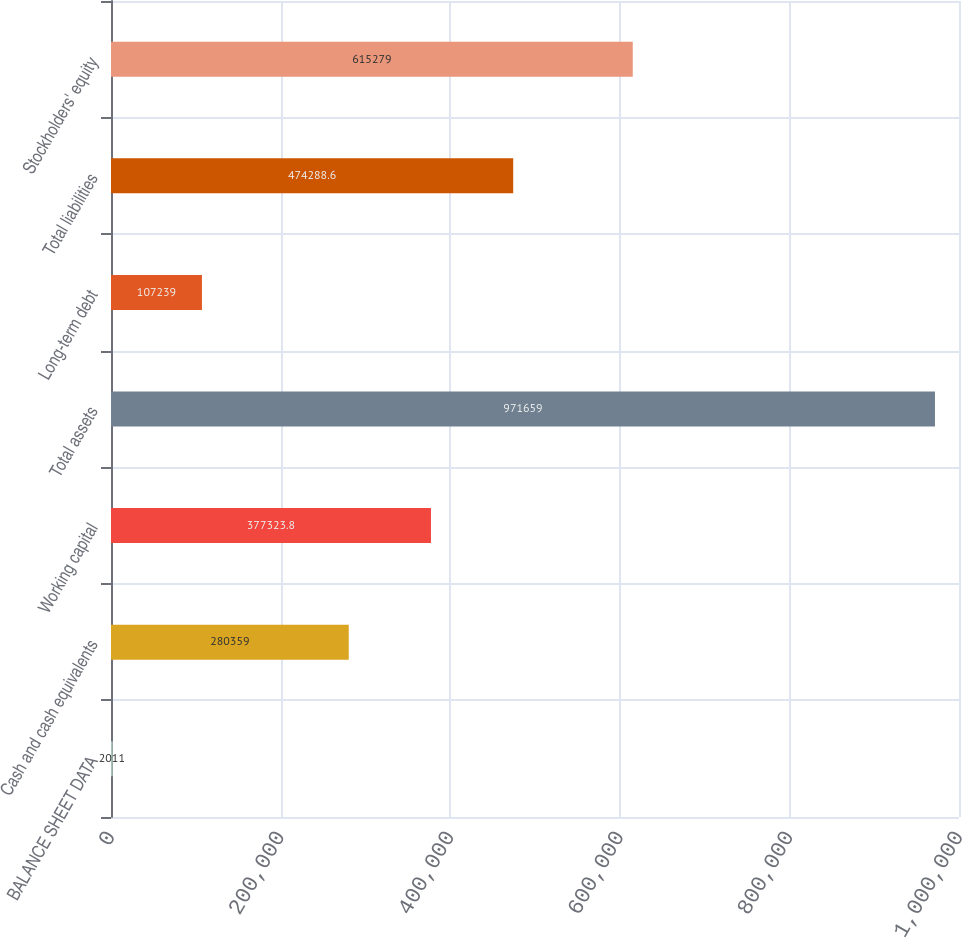Convert chart. <chart><loc_0><loc_0><loc_500><loc_500><bar_chart><fcel>BALANCE SHEET DATA<fcel>Cash and cash equivalents<fcel>Working capital<fcel>Total assets<fcel>Long-term debt<fcel>Total liabilities<fcel>Stockholders' equity<nl><fcel>2011<fcel>280359<fcel>377324<fcel>971659<fcel>107239<fcel>474289<fcel>615279<nl></chart> 